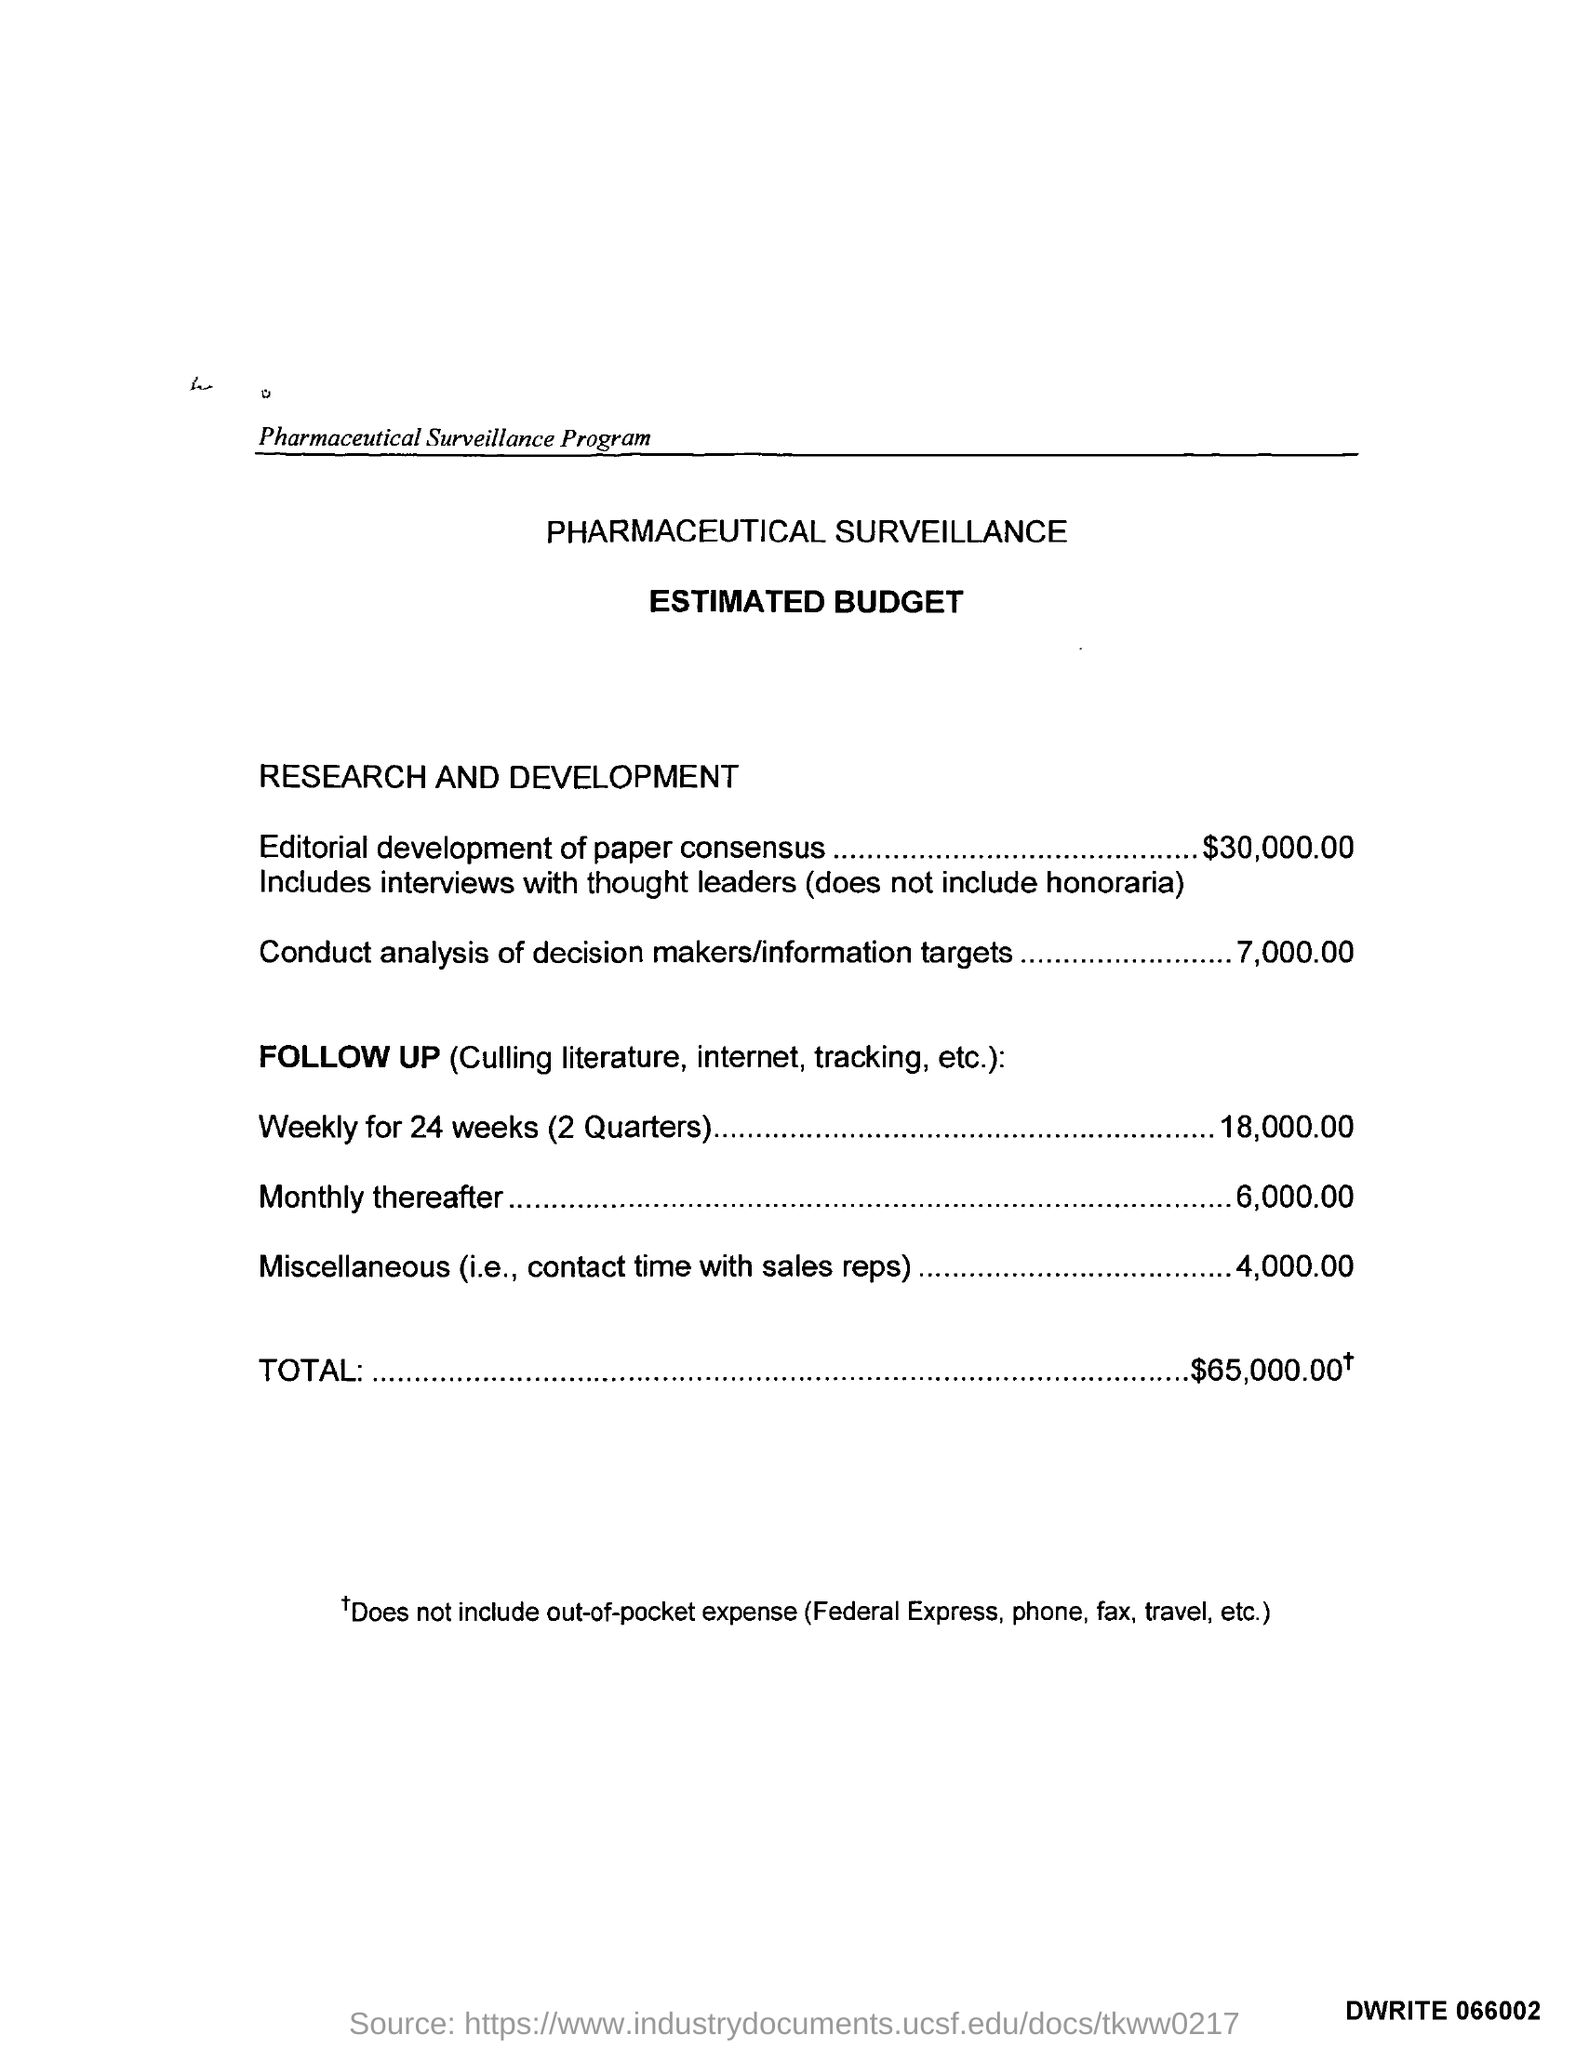what is the estimated budget given for conduct analysis of decision makers/information targets ?
 7,000.00 